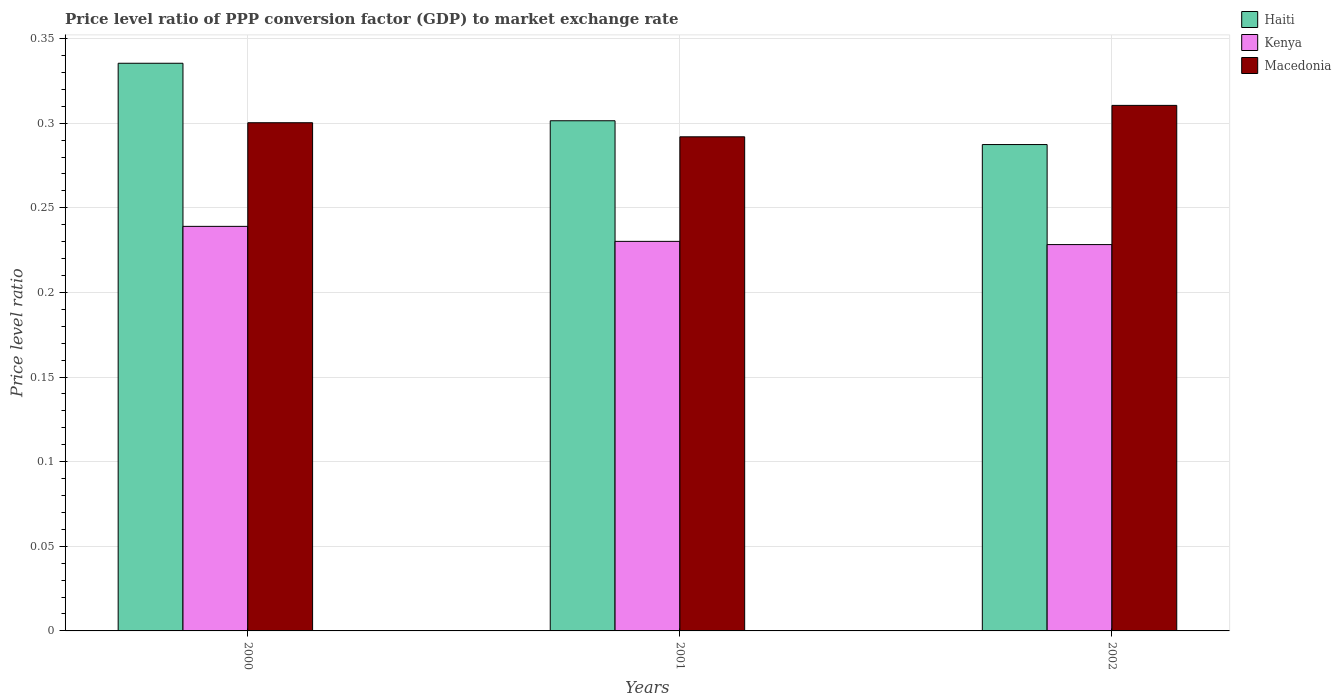How many different coloured bars are there?
Offer a very short reply. 3. Are the number of bars on each tick of the X-axis equal?
Make the answer very short. Yes. In how many cases, is the number of bars for a given year not equal to the number of legend labels?
Give a very brief answer. 0. What is the price level ratio in Kenya in 2002?
Your answer should be very brief. 0.23. Across all years, what is the maximum price level ratio in Kenya?
Offer a terse response. 0.24. Across all years, what is the minimum price level ratio in Kenya?
Offer a terse response. 0.23. What is the total price level ratio in Haiti in the graph?
Your answer should be compact. 0.92. What is the difference between the price level ratio in Haiti in 2000 and that in 2001?
Your response must be concise. 0.03. What is the difference between the price level ratio in Haiti in 2000 and the price level ratio in Macedonia in 2002?
Offer a very short reply. 0.02. What is the average price level ratio in Macedonia per year?
Provide a short and direct response. 0.3. In the year 2001, what is the difference between the price level ratio in Macedonia and price level ratio in Kenya?
Offer a very short reply. 0.06. What is the ratio of the price level ratio in Haiti in 2000 to that in 2002?
Provide a short and direct response. 1.17. What is the difference between the highest and the second highest price level ratio in Haiti?
Provide a succinct answer. 0.03. What is the difference between the highest and the lowest price level ratio in Macedonia?
Your answer should be compact. 0.02. What does the 1st bar from the left in 2001 represents?
Make the answer very short. Haiti. What does the 3rd bar from the right in 2001 represents?
Your answer should be very brief. Haiti. Is it the case that in every year, the sum of the price level ratio in Haiti and price level ratio in Macedonia is greater than the price level ratio in Kenya?
Your answer should be compact. Yes. What is the difference between two consecutive major ticks on the Y-axis?
Provide a succinct answer. 0.05. Are the values on the major ticks of Y-axis written in scientific E-notation?
Your answer should be very brief. No. Does the graph contain any zero values?
Provide a succinct answer. No. What is the title of the graph?
Offer a terse response. Price level ratio of PPP conversion factor (GDP) to market exchange rate. Does "Grenada" appear as one of the legend labels in the graph?
Give a very brief answer. No. What is the label or title of the Y-axis?
Your answer should be compact. Price level ratio. What is the Price level ratio in Haiti in 2000?
Offer a terse response. 0.34. What is the Price level ratio of Kenya in 2000?
Give a very brief answer. 0.24. What is the Price level ratio of Macedonia in 2000?
Make the answer very short. 0.3. What is the Price level ratio of Haiti in 2001?
Your answer should be compact. 0.3. What is the Price level ratio in Kenya in 2001?
Ensure brevity in your answer.  0.23. What is the Price level ratio in Macedonia in 2001?
Provide a succinct answer. 0.29. What is the Price level ratio of Haiti in 2002?
Provide a short and direct response. 0.29. What is the Price level ratio of Kenya in 2002?
Offer a terse response. 0.23. What is the Price level ratio of Macedonia in 2002?
Provide a short and direct response. 0.31. Across all years, what is the maximum Price level ratio in Haiti?
Your answer should be very brief. 0.34. Across all years, what is the maximum Price level ratio in Kenya?
Keep it short and to the point. 0.24. Across all years, what is the maximum Price level ratio of Macedonia?
Your answer should be compact. 0.31. Across all years, what is the minimum Price level ratio of Haiti?
Provide a short and direct response. 0.29. Across all years, what is the minimum Price level ratio of Kenya?
Provide a succinct answer. 0.23. Across all years, what is the minimum Price level ratio in Macedonia?
Keep it short and to the point. 0.29. What is the total Price level ratio of Haiti in the graph?
Provide a short and direct response. 0.92. What is the total Price level ratio in Kenya in the graph?
Your response must be concise. 0.7. What is the total Price level ratio of Macedonia in the graph?
Your answer should be very brief. 0.9. What is the difference between the Price level ratio of Haiti in 2000 and that in 2001?
Offer a terse response. 0.03. What is the difference between the Price level ratio in Kenya in 2000 and that in 2001?
Keep it short and to the point. 0.01. What is the difference between the Price level ratio of Macedonia in 2000 and that in 2001?
Provide a succinct answer. 0.01. What is the difference between the Price level ratio in Haiti in 2000 and that in 2002?
Keep it short and to the point. 0.05. What is the difference between the Price level ratio of Kenya in 2000 and that in 2002?
Provide a succinct answer. 0.01. What is the difference between the Price level ratio of Macedonia in 2000 and that in 2002?
Give a very brief answer. -0.01. What is the difference between the Price level ratio of Haiti in 2001 and that in 2002?
Offer a very short reply. 0.01. What is the difference between the Price level ratio of Kenya in 2001 and that in 2002?
Keep it short and to the point. 0. What is the difference between the Price level ratio in Macedonia in 2001 and that in 2002?
Make the answer very short. -0.02. What is the difference between the Price level ratio of Haiti in 2000 and the Price level ratio of Kenya in 2001?
Offer a very short reply. 0.11. What is the difference between the Price level ratio in Haiti in 2000 and the Price level ratio in Macedonia in 2001?
Make the answer very short. 0.04. What is the difference between the Price level ratio in Kenya in 2000 and the Price level ratio in Macedonia in 2001?
Your response must be concise. -0.05. What is the difference between the Price level ratio of Haiti in 2000 and the Price level ratio of Kenya in 2002?
Your answer should be compact. 0.11. What is the difference between the Price level ratio of Haiti in 2000 and the Price level ratio of Macedonia in 2002?
Offer a terse response. 0.02. What is the difference between the Price level ratio of Kenya in 2000 and the Price level ratio of Macedonia in 2002?
Keep it short and to the point. -0.07. What is the difference between the Price level ratio in Haiti in 2001 and the Price level ratio in Kenya in 2002?
Offer a very short reply. 0.07. What is the difference between the Price level ratio in Haiti in 2001 and the Price level ratio in Macedonia in 2002?
Offer a very short reply. -0.01. What is the difference between the Price level ratio in Kenya in 2001 and the Price level ratio in Macedonia in 2002?
Offer a very short reply. -0.08. What is the average Price level ratio in Haiti per year?
Your response must be concise. 0.31. What is the average Price level ratio of Kenya per year?
Provide a short and direct response. 0.23. What is the average Price level ratio of Macedonia per year?
Provide a succinct answer. 0.3. In the year 2000, what is the difference between the Price level ratio of Haiti and Price level ratio of Kenya?
Your response must be concise. 0.1. In the year 2000, what is the difference between the Price level ratio of Haiti and Price level ratio of Macedonia?
Your answer should be very brief. 0.04. In the year 2000, what is the difference between the Price level ratio of Kenya and Price level ratio of Macedonia?
Offer a very short reply. -0.06. In the year 2001, what is the difference between the Price level ratio in Haiti and Price level ratio in Kenya?
Your response must be concise. 0.07. In the year 2001, what is the difference between the Price level ratio in Haiti and Price level ratio in Macedonia?
Provide a short and direct response. 0.01. In the year 2001, what is the difference between the Price level ratio in Kenya and Price level ratio in Macedonia?
Provide a succinct answer. -0.06. In the year 2002, what is the difference between the Price level ratio of Haiti and Price level ratio of Kenya?
Your answer should be very brief. 0.06. In the year 2002, what is the difference between the Price level ratio of Haiti and Price level ratio of Macedonia?
Give a very brief answer. -0.02. In the year 2002, what is the difference between the Price level ratio of Kenya and Price level ratio of Macedonia?
Offer a terse response. -0.08. What is the ratio of the Price level ratio of Haiti in 2000 to that in 2001?
Provide a succinct answer. 1.11. What is the ratio of the Price level ratio in Macedonia in 2000 to that in 2001?
Make the answer very short. 1.03. What is the ratio of the Price level ratio of Haiti in 2000 to that in 2002?
Your answer should be compact. 1.17. What is the ratio of the Price level ratio in Kenya in 2000 to that in 2002?
Offer a very short reply. 1.05. What is the ratio of the Price level ratio of Haiti in 2001 to that in 2002?
Ensure brevity in your answer.  1.05. What is the ratio of the Price level ratio of Kenya in 2001 to that in 2002?
Your answer should be very brief. 1.01. What is the ratio of the Price level ratio of Macedonia in 2001 to that in 2002?
Make the answer very short. 0.94. What is the difference between the highest and the second highest Price level ratio in Haiti?
Give a very brief answer. 0.03. What is the difference between the highest and the second highest Price level ratio in Kenya?
Provide a short and direct response. 0.01. What is the difference between the highest and the second highest Price level ratio of Macedonia?
Keep it short and to the point. 0.01. What is the difference between the highest and the lowest Price level ratio in Haiti?
Offer a very short reply. 0.05. What is the difference between the highest and the lowest Price level ratio of Kenya?
Make the answer very short. 0.01. What is the difference between the highest and the lowest Price level ratio of Macedonia?
Make the answer very short. 0.02. 